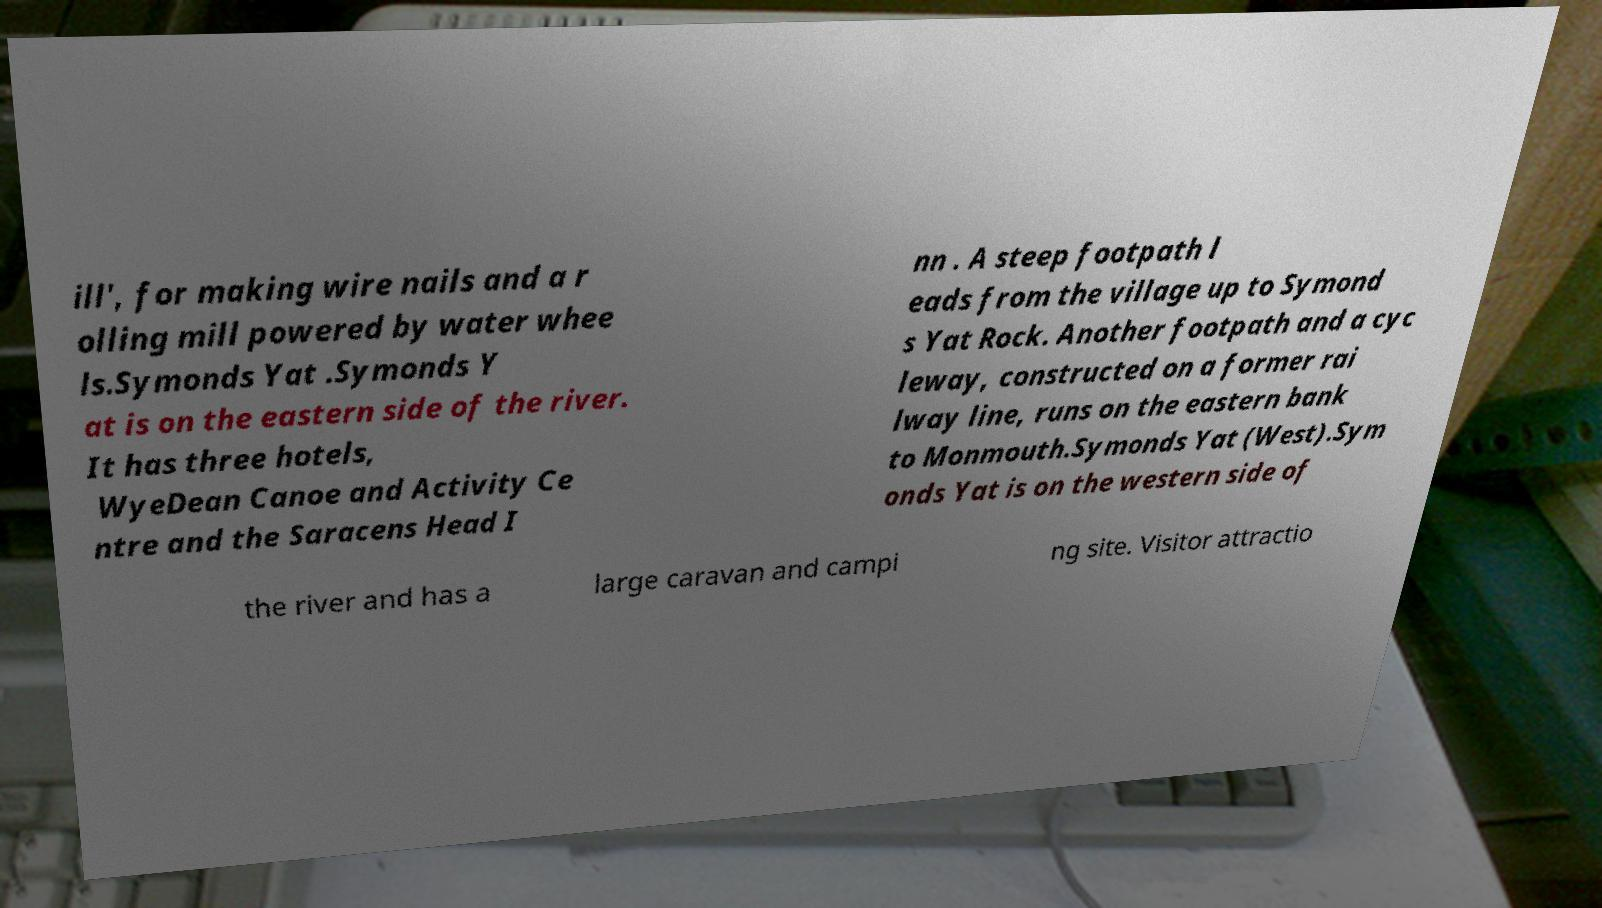Could you extract and type out the text from this image? ill', for making wire nails and a r olling mill powered by water whee ls.Symonds Yat .Symonds Y at is on the eastern side of the river. It has three hotels, WyeDean Canoe and Activity Ce ntre and the Saracens Head I nn . A steep footpath l eads from the village up to Symond s Yat Rock. Another footpath and a cyc leway, constructed on a former rai lway line, runs on the eastern bank to Monmouth.Symonds Yat (West).Sym onds Yat is on the western side of the river and has a large caravan and campi ng site. Visitor attractio 